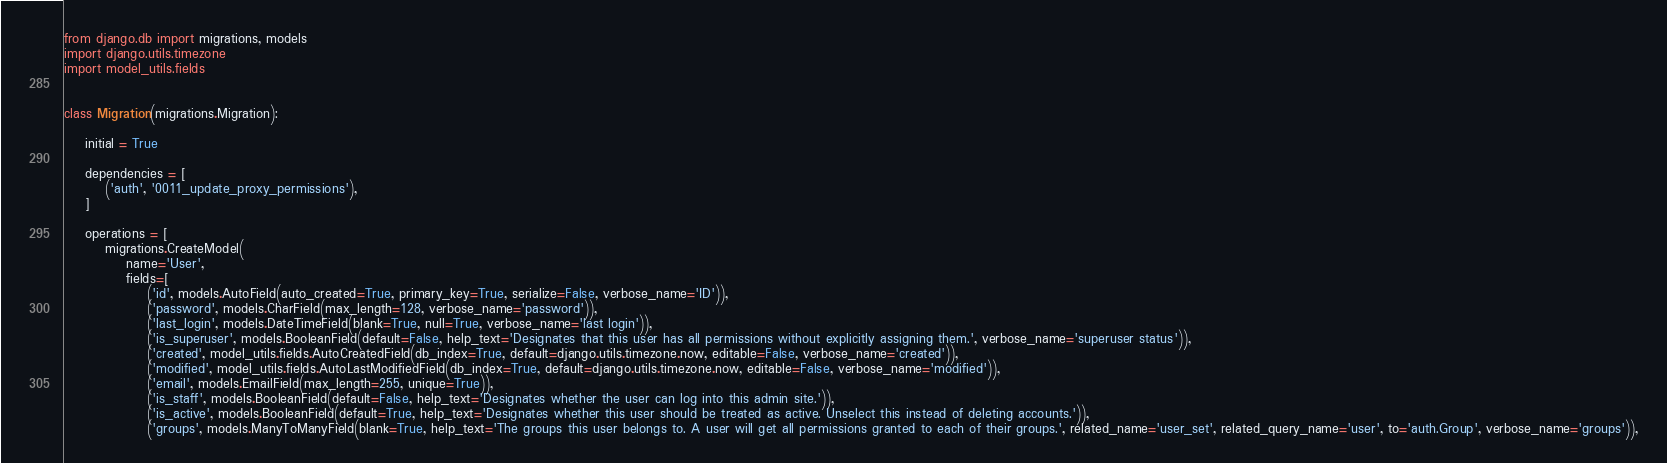<code> <loc_0><loc_0><loc_500><loc_500><_Python_>from django.db import migrations, models
import django.utils.timezone
import model_utils.fields


class Migration(migrations.Migration):

    initial = True

    dependencies = [
        ('auth', '0011_update_proxy_permissions'),
    ]

    operations = [
        migrations.CreateModel(
            name='User',
            fields=[
                ('id', models.AutoField(auto_created=True, primary_key=True, serialize=False, verbose_name='ID')),
                ('password', models.CharField(max_length=128, verbose_name='password')),
                ('last_login', models.DateTimeField(blank=True, null=True, verbose_name='last login')),
                ('is_superuser', models.BooleanField(default=False, help_text='Designates that this user has all permissions without explicitly assigning them.', verbose_name='superuser status')),
                ('created', model_utils.fields.AutoCreatedField(db_index=True, default=django.utils.timezone.now, editable=False, verbose_name='created')),
                ('modified', model_utils.fields.AutoLastModifiedField(db_index=True, default=django.utils.timezone.now, editable=False, verbose_name='modified')),
                ('email', models.EmailField(max_length=255, unique=True)),
                ('is_staff', models.BooleanField(default=False, help_text='Designates whether the user can log into this admin site.')),
                ('is_active', models.BooleanField(default=True, help_text='Designates whether this user should be treated as active. Unselect this instead of deleting accounts.')),
                ('groups', models.ManyToManyField(blank=True, help_text='The groups this user belongs to. A user will get all permissions granted to each of their groups.', related_name='user_set', related_query_name='user', to='auth.Group', verbose_name='groups')),</code> 